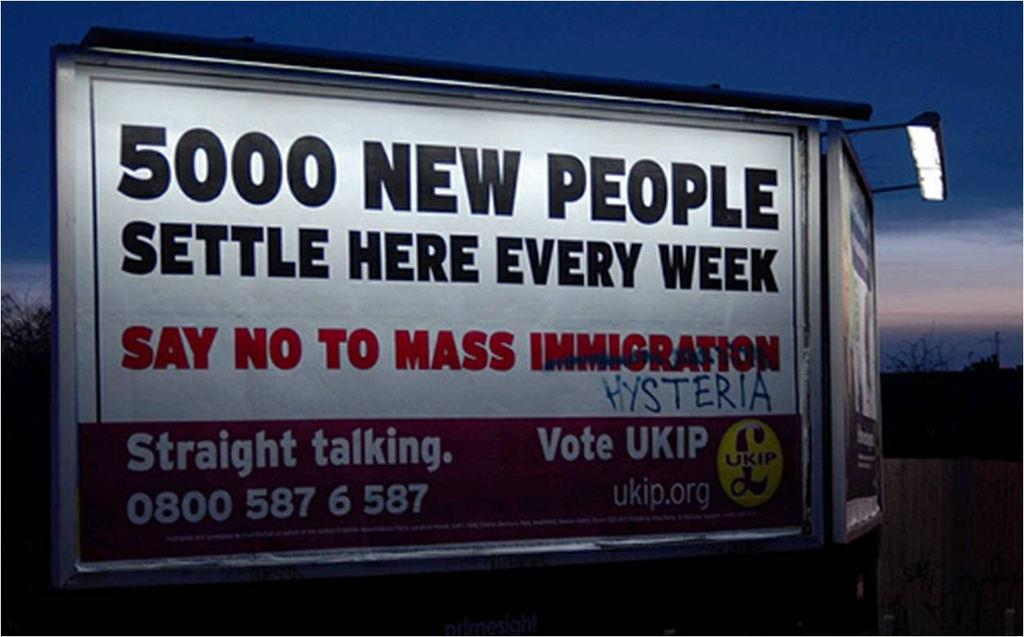<image>
Provide a brief description of the given image. A billboard  for boycotting mass immigration has been altered with spray paint. 